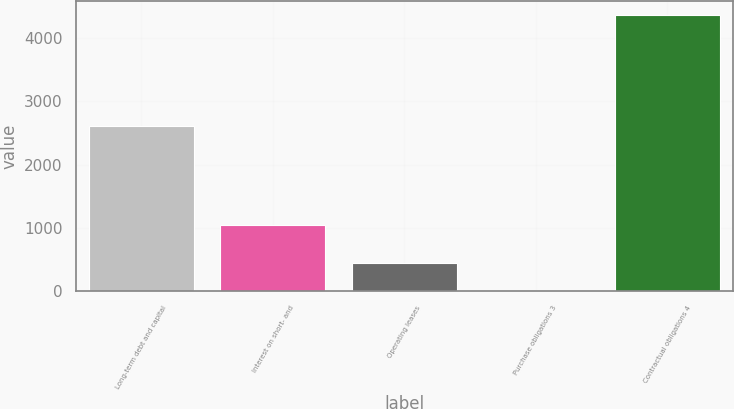Convert chart to OTSL. <chart><loc_0><loc_0><loc_500><loc_500><bar_chart><fcel>Long-term debt and capital<fcel>Interest on short- and<fcel>Operating leases<fcel>Purchase obligations 3<fcel>Contractual obligations 4<nl><fcel>2612<fcel>1048<fcel>445<fcel>9<fcel>4369<nl></chart> 